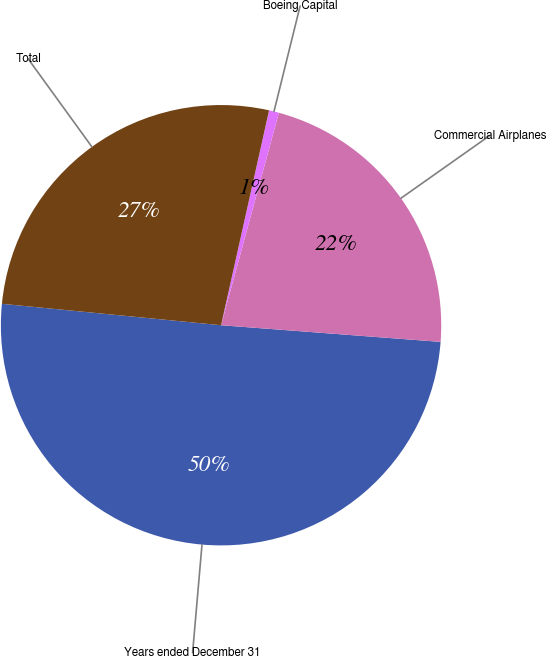<chart> <loc_0><loc_0><loc_500><loc_500><pie_chart><fcel>Years ended December 31<fcel>Commercial Airplanes<fcel>Boeing Capital<fcel>Total<nl><fcel>50.35%<fcel>21.98%<fcel>0.73%<fcel>26.95%<nl></chart> 